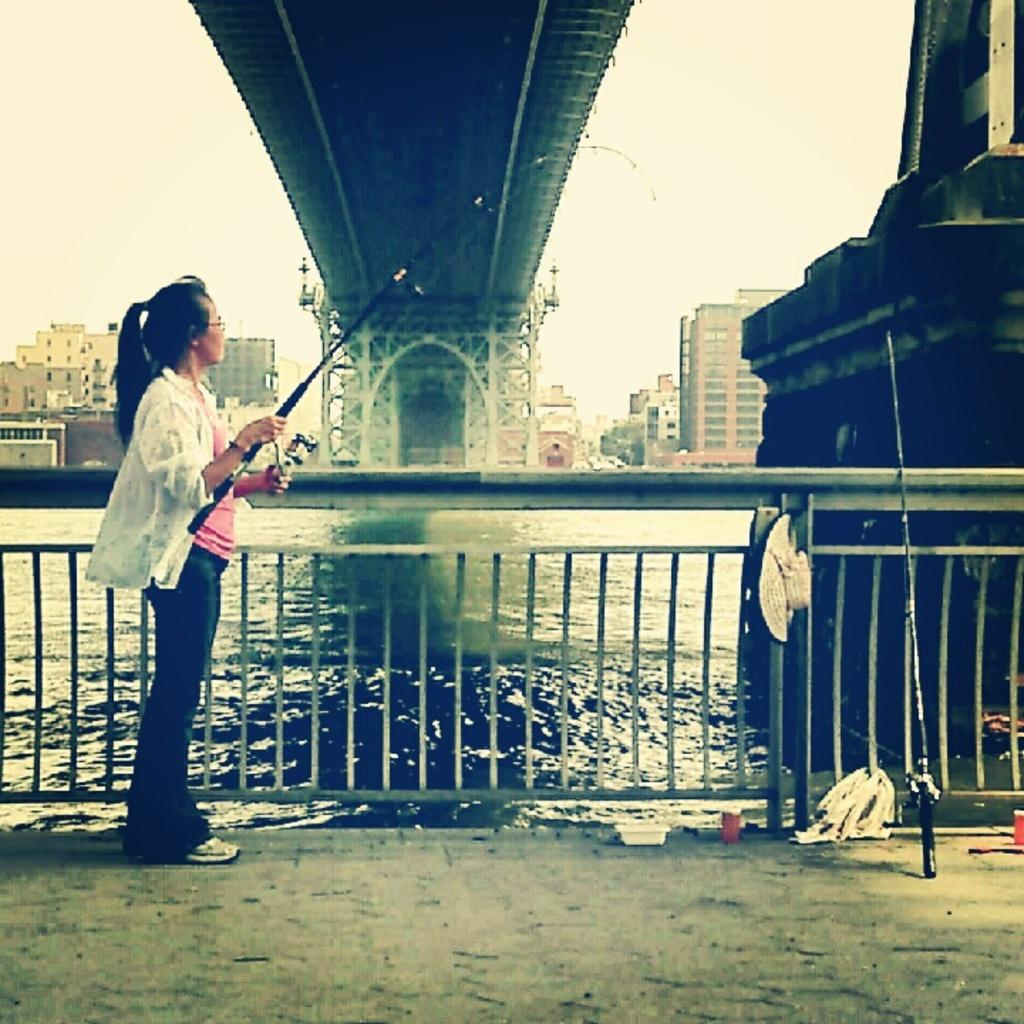What is the lady in the image doing? The lady in the image is fishing. What tools is she using for fishing? There are fishing rods in the image. What is the lady wearing on her head? There is a hat in the image. What type of structures can be seen in the image? There are buildings and a bridge in the image. What type of barrier is present in the image? There is fencing in the image. What natural element is visible in the image? There is water visible in the image. What part of the natural environment is visible in the image? The sky is visible in the image. What type of apparel is the lady wearing on her mind in the image? There is no mention of the lady wearing any apparel on her mind in the image. 